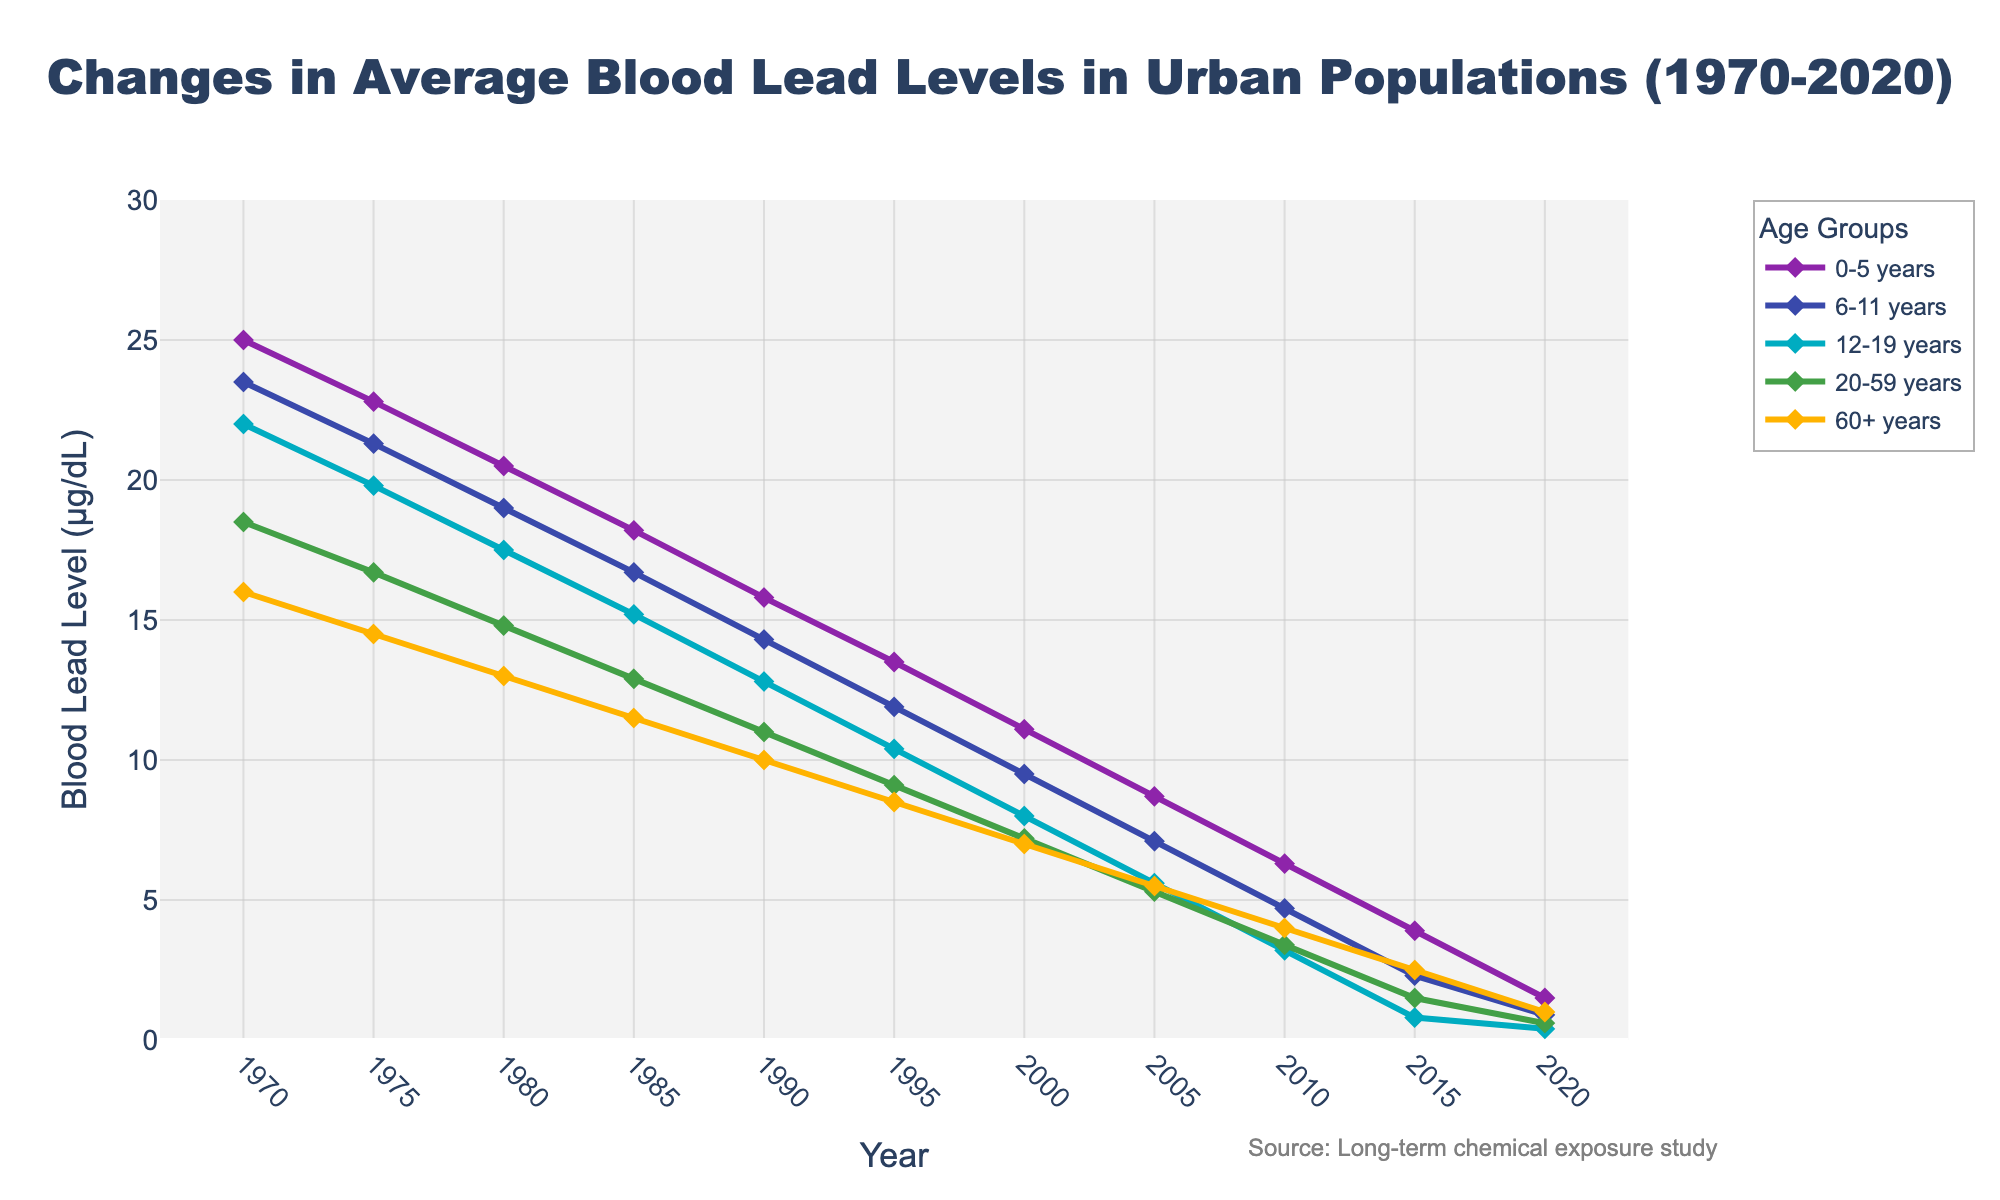What is the overall trend in blood lead levels for all age groups from 1970 to 2020? The overall trend in blood lead levels for all age groups from 1970 to 2020 shows a significant decline. Each line representing an age group decreases over time, indicating a reduction in blood lead levels across all age groups.
Answer: Significant decline Which age group had the highest blood lead level in 1970, and what was the value? Looking at the figure, the age group 0-5 years had the highest blood lead level in 1970, with a value of 25.0 µg/dL.
Answer: 0-5 years, 25.0 µg/dL How do the blood lead levels for age groups 0-5 years and 60+ years compare in 2020? In 2020, the blood lead level for the age group 0-5 years is 1.5 µg/dL, while for the age group 60+ years, it is 1.0 µg/dL. The 0-5 years age group has a higher blood lead level compared to the 60+ years age group.
Answer: 0-5 years higher During which year did the age group 12-19 years first drop below 10 µg/dL? The blood lead levels for the 12-19 years age group first dropped below 10 µg/dL around 2000, as observed in the figure.
Answer: 2000 Between which consecutive years did the age group 6-11 years see the greatest decrease in blood lead levels? The age group 6-11 years saw the greatest decrease between 2010 and 2015. The levels dropped from 4.7 µg/dL in 2010 to 2.3 µg/dL in 2015, which is a decrease of 2.4 µg/dL.
Answer: 2010-2015 What's the average blood lead level of the 20-59 years age group for the years 1980, 1985, and 1990? The values are 14.8 µg/dL (1980), 12.9 µg/dL (1985), and 11.0 µg/dL (1990). The average is calculated as (14.8 + 12.9 + 11.0) / 3 = 12.9 µg/dL.
Answer: 12.9 µg/dL Looking at the visual representation, which color represents the age group 0-5 years? The line color representing the age group 0-5 years is purple. This can be identified from the legend on the chart.
Answer: Purple In 2015, how much higher were the blood lead levels for the age group 60+ years compared to the 12-19 years group? In 2015, the blood lead levels for the 60+ years group were 2.5 µg/dL, while for the 12-19 years group, it was 0.8 µg/dL. Therefore, the 60+ years group had levels 1.7 µg/dL higher.
Answer: 1.7 µg/dL What is the rate of change in the blood lead levels of the 0-5 years age group from 1970 to 2020? The blood lead levels for the 0-5 years age group decreased from 25.0 µg/dL in 1970 to 1.5 µg/dL in 2020. The rate of change is (25.0 - 1.5) / (2020 - 1970) = 23.5 / 50 = 0.47 µg/dL per year.
Answer: 0.47 µg/dL per year 